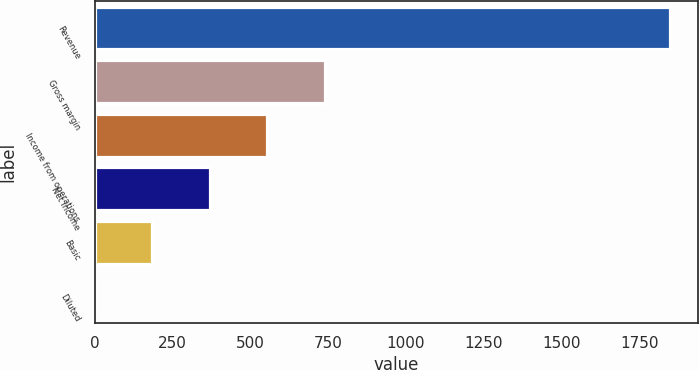Convert chart to OTSL. <chart><loc_0><loc_0><loc_500><loc_500><bar_chart><fcel>Revenue<fcel>Gross margin<fcel>Income from operations<fcel>Net income<fcel>Basic<fcel>Diluted<nl><fcel>1847<fcel>738.97<fcel>554.3<fcel>369.63<fcel>184.96<fcel>0.29<nl></chart> 